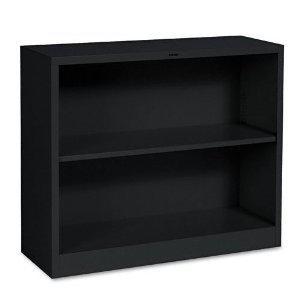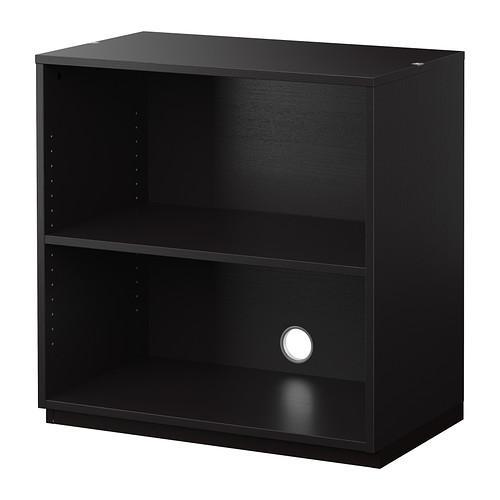The first image is the image on the left, the second image is the image on the right. Examine the images to the left and right. Is the description "The left and right image contains the same number shelves facing opposite ways." accurate? Answer yes or no. Yes. The first image is the image on the left, the second image is the image on the right. Analyze the images presented: Is the assertion "Two bookcases are wider than they are tall and have two inner shelves, but only one sits flush on the floor." valid? Answer yes or no. No. 